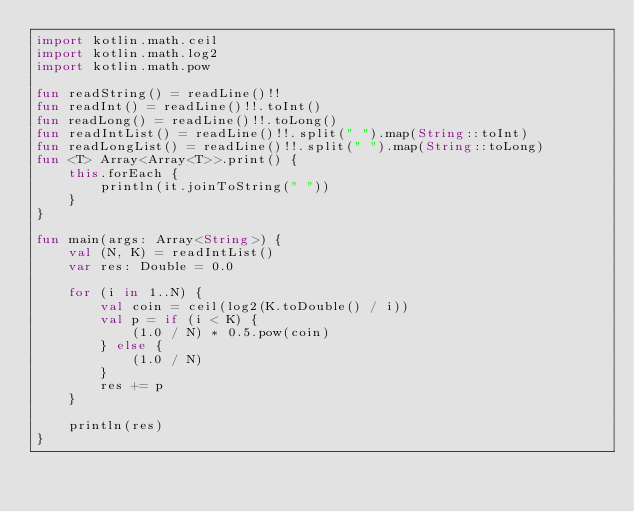Convert code to text. <code><loc_0><loc_0><loc_500><loc_500><_Kotlin_>import kotlin.math.ceil
import kotlin.math.log2
import kotlin.math.pow

fun readString() = readLine()!!
fun readInt() = readLine()!!.toInt()
fun readLong() = readLine()!!.toLong()
fun readIntList() = readLine()!!.split(" ").map(String::toInt)
fun readLongList() = readLine()!!.split(" ").map(String::toLong)
fun <T> Array<Array<T>>.print() {
    this.forEach {
        println(it.joinToString(" "))
    }
}

fun main(args: Array<String>) {
    val (N, K) = readIntList()
    var res: Double = 0.0

    for (i in 1..N) {
        val coin = ceil(log2(K.toDouble() / i))
        val p = if (i < K) {
            (1.0 / N) * 0.5.pow(coin)
        } else {
            (1.0 / N)
        }
        res += p
    }

    println(res)
}</code> 